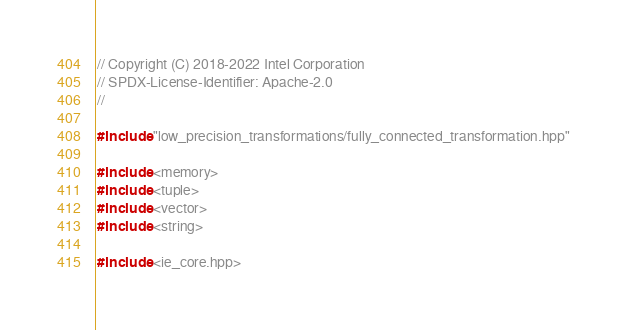<code> <loc_0><loc_0><loc_500><loc_500><_C++_>// Copyright (C) 2018-2022 Intel Corporation
// SPDX-License-Identifier: Apache-2.0
//

#include "low_precision_transformations/fully_connected_transformation.hpp"

#include <memory>
#include <tuple>
#include <vector>
#include <string>

#include <ie_core.hpp>
</code> 